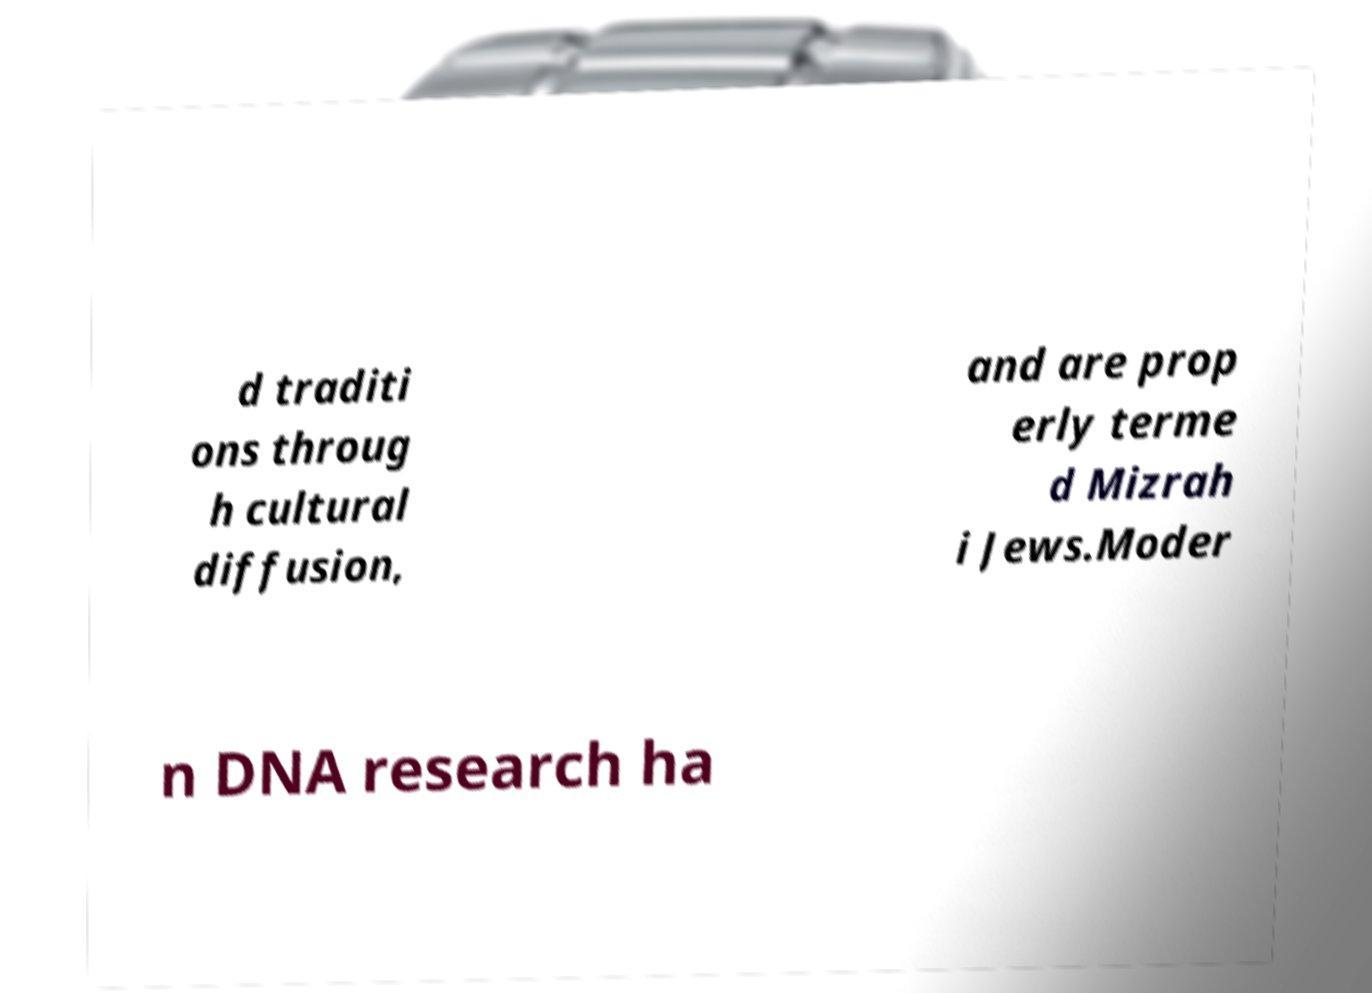Can you accurately transcribe the text from the provided image for me? d traditi ons throug h cultural diffusion, and are prop erly terme d Mizrah i Jews.Moder n DNA research ha 